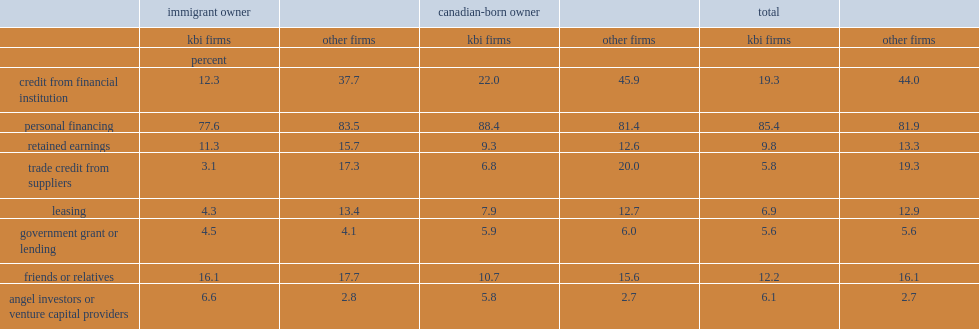What percent of all start-ups in the sample used personal financing? 83.65. What percent of canadian-born entrepreneurs used personal financing to start a kbi business? 88.4. What percent of immigrant entrepreneurs used personal financing to start a kbi business. 77.6. What percent of canadian-born entrepreneurs used friends and relatives as a financing source to start a kbi business? 10.7. Which type of start-ups is much less likely to use debt financing from formal financial institutions? start-ups from other industries or kbi start-ups? Kbi firms. What percent of start-ups in non-kbi industries turned to debt financing from a financial institution? 44.0. What percent of immigrant-owned kbi start-ups turned to debt financing from a formal financial institution? 12.3. Which type of start-up is less likely to use trade credit financing? kbi start-ups or non-kbi firms? Kbi firms. Which sources were used more often by kbi firms than by non-kbi firms? Angel investors or venture capital providers. What percent of kbi start-ups turned to angel investors or venture capital financing? 6.1. 